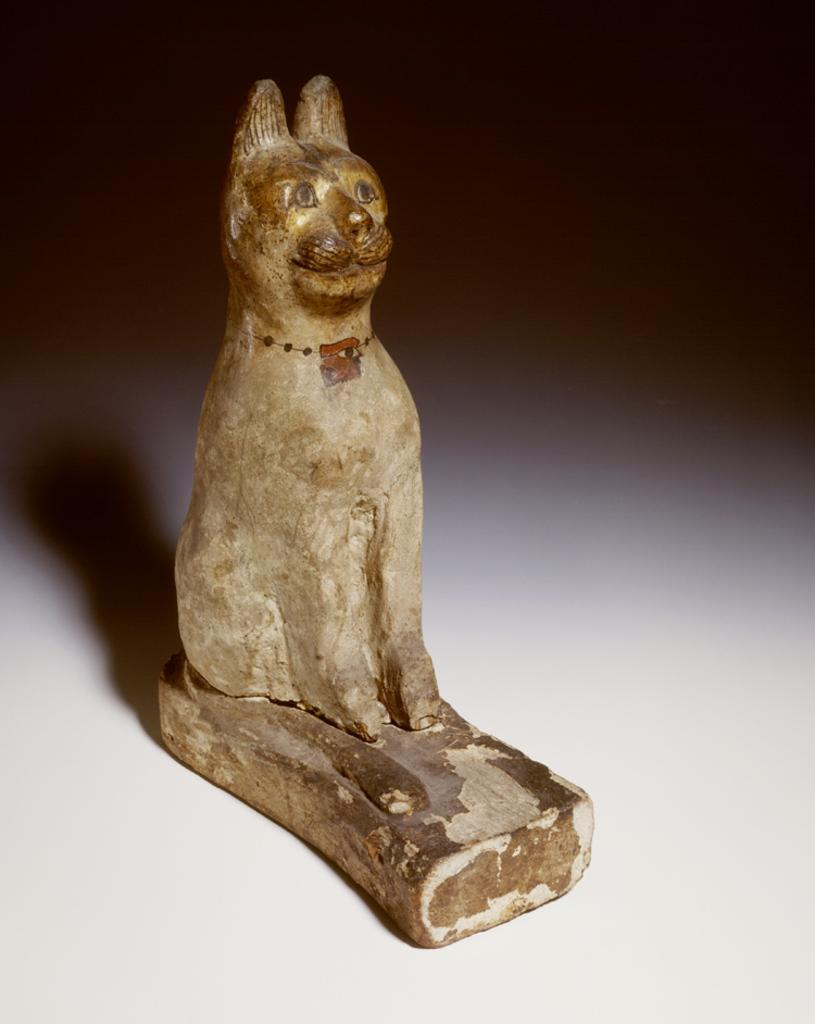What type of toy is visible in the image? There is a wooden dog toy in the image. What material is the toy made of? The wooden dog toy is made of wood. What is the color of the surface on which the toy is placed? The wooden dog toy is present on a white surface. What property does the wooden dog toy have that allows it to point in a specific direction? The wooden dog toy does not have any property that allows it to point in a specific direction, as it is a static object in the image. 